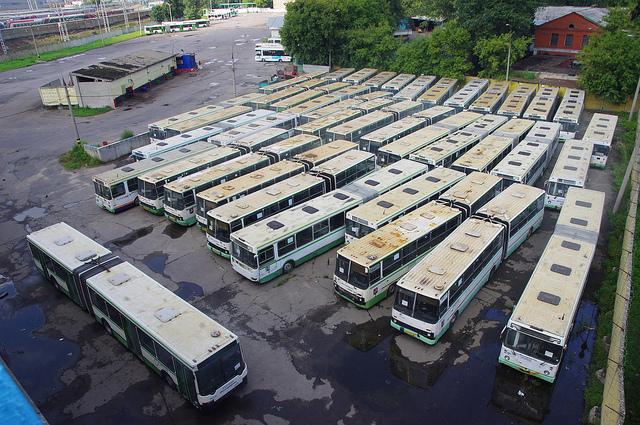What likely caused the rust on the top of some of the buses?
Short answer required. Rain. Is this a junkyard?
Short answer required. No. Is this a commercial bus parking lot?
Quick response, please. Yes. What type of vehicle sits in front of the buses?
Short answer required. Bus. How many lanes are in the larger pool?
Quick response, please. 12. Was this photo taken in a store?
Keep it brief. No. How many pools are there?
Quick response, please. 0. 